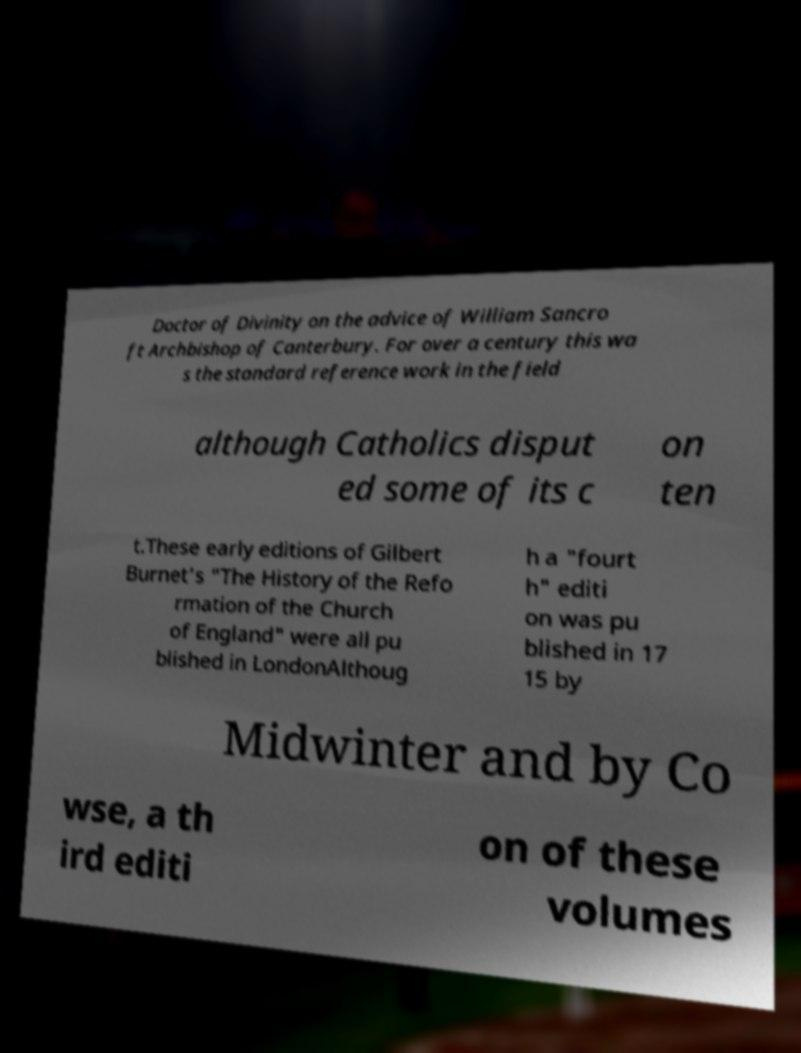I need the written content from this picture converted into text. Can you do that? Doctor of Divinity on the advice of William Sancro ft Archbishop of Canterbury. For over a century this wa s the standard reference work in the field although Catholics disput ed some of its c on ten t.These early editions of Gilbert Burnet's "The History of the Refo rmation of the Church of England" were all pu blished in LondonAlthoug h a "fourt h" editi on was pu blished in 17 15 by Midwinter and by Co wse, a th ird editi on of these volumes 